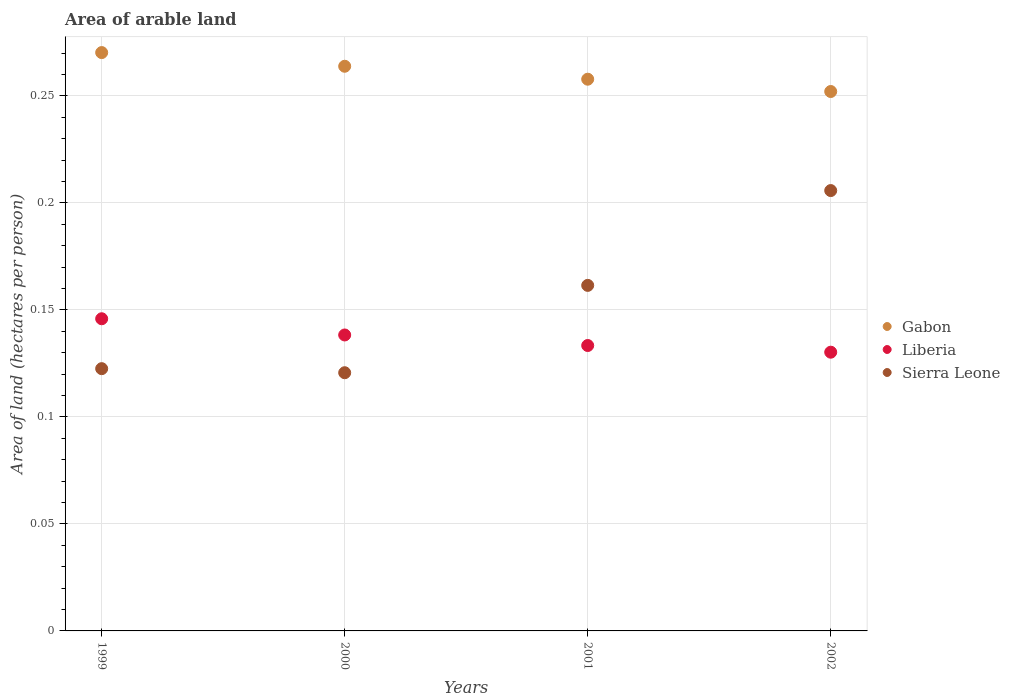How many different coloured dotlines are there?
Your answer should be very brief. 3. Is the number of dotlines equal to the number of legend labels?
Offer a terse response. Yes. What is the total arable land in Gabon in 2002?
Offer a terse response. 0.25. Across all years, what is the maximum total arable land in Sierra Leone?
Make the answer very short. 0.21. Across all years, what is the minimum total arable land in Sierra Leone?
Make the answer very short. 0.12. In which year was the total arable land in Gabon minimum?
Provide a succinct answer. 2002. What is the total total arable land in Liberia in the graph?
Offer a terse response. 0.55. What is the difference between the total arable land in Sierra Leone in 2001 and that in 2002?
Offer a terse response. -0.04. What is the difference between the total arable land in Liberia in 2002 and the total arable land in Gabon in 2000?
Keep it short and to the point. -0.13. What is the average total arable land in Liberia per year?
Offer a terse response. 0.14. In the year 2001, what is the difference between the total arable land in Liberia and total arable land in Gabon?
Make the answer very short. -0.12. What is the ratio of the total arable land in Sierra Leone in 1999 to that in 2000?
Make the answer very short. 1.02. Is the total arable land in Gabon in 1999 less than that in 2000?
Offer a very short reply. No. What is the difference between the highest and the second highest total arable land in Sierra Leone?
Your response must be concise. 0.04. What is the difference between the highest and the lowest total arable land in Liberia?
Keep it short and to the point. 0.02. In how many years, is the total arable land in Gabon greater than the average total arable land in Gabon taken over all years?
Your response must be concise. 2. Is the sum of the total arable land in Gabon in 2001 and 2002 greater than the maximum total arable land in Sierra Leone across all years?
Your answer should be compact. Yes. Does the total arable land in Sierra Leone monotonically increase over the years?
Keep it short and to the point. No. Is the total arable land in Liberia strictly less than the total arable land in Sierra Leone over the years?
Give a very brief answer. No. Are the values on the major ticks of Y-axis written in scientific E-notation?
Your response must be concise. No. How are the legend labels stacked?
Provide a short and direct response. Vertical. What is the title of the graph?
Make the answer very short. Area of arable land. Does "American Samoa" appear as one of the legend labels in the graph?
Offer a terse response. No. What is the label or title of the Y-axis?
Give a very brief answer. Area of land (hectares per person). What is the Area of land (hectares per person) in Gabon in 1999?
Your answer should be very brief. 0.27. What is the Area of land (hectares per person) of Liberia in 1999?
Make the answer very short. 0.15. What is the Area of land (hectares per person) in Sierra Leone in 1999?
Your response must be concise. 0.12. What is the Area of land (hectares per person) in Gabon in 2000?
Your response must be concise. 0.26. What is the Area of land (hectares per person) in Liberia in 2000?
Make the answer very short. 0.14. What is the Area of land (hectares per person) in Sierra Leone in 2000?
Give a very brief answer. 0.12. What is the Area of land (hectares per person) in Gabon in 2001?
Offer a terse response. 0.26. What is the Area of land (hectares per person) in Liberia in 2001?
Your response must be concise. 0.13. What is the Area of land (hectares per person) of Sierra Leone in 2001?
Offer a very short reply. 0.16. What is the Area of land (hectares per person) in Gabon in 2002?
Ensure brevity in your answer.  0.25. What is the Area of land (hectares per person) of Liberia in 2002?
Offer a terse response. 0.13. What is the Area of land (hectares per person) of Sierra Leone in 2002?
Offer a very short reply. 0.21. Across all years, what is the maximum Area of land (hectares per person) of Gabon?
Your answer should be very brief. 0.27. Across all years, what is the maximum Area of land (hectares per person) in Liberia?
Your answer should be very brief. 0.15. Across all years, what is the maximum Area of land (hectares per person) of Sierra Leone?
Offer a very short reply. 0.21. Across all years, what is the minimum Area of land (hectares per person) of Gabon?
Your answer should be very brief. 0.25. Across all years, what is the minimum Area of land (hectares per person) of Liberia?
Your answer should be compact. 0.13. Across all years, what is the minimum Area of land (hectares per person) of Sierra Leone?
Your answer should be very brief. 0.12. What is the total Area of land (hectares per person) of Gabon in the graph?
Keep it short and to the point. 1.04. What is the total Area of land (hectares per person) in Liberia in the graph?
Your answer should be compact. 0.55. What is the total Area of land (hectares per person) of Sierra Leone in the graph?
Make the answer very short. 0.61. What is the difference between the Area of land (hectares per person) of Gabon in 1999 and that in 2000?
Provide a short and direct response. 0.01. What is the difference between the Area of land (hectares per person) in Liberia in 1999 and that in 2000?
Give a very brief answer. 0.01. What is the difference between the Area of land (hectares per person) of Sierra Leone in 1999 and that in 2000?
Provide a succinct answer. 0. What is the difference between the Area of land (hectares per person) of Gabon in 1999 and that in 2001?
Keep it short and to the point. 0.01. What is the difference between the Area of land (hectares per person) in Liberia in 1999 and that in 2001?
Your answer should be compact. 0.01. What is the difference between the Area of land (hectares per person) in Sierra Leone in 1999 and that in 2001?
Provide a short and direct response. -0.04. What is the difference between the Area of land (hectares per person) in Gabon in 1999 and that in 2002?
Provide a short and direct response. 0.02. What is the difference between the Area of land (hectares per person) in Liberia in 1999 and that in 2002?
Keep it short and to the point. 0.02. What is the difference between the Area of land (hectares per person) in Sierra Leone in 1999 and that in 2002?
Ensure brevity in your answer.  -0.08. What is the difference between the Area of land (hectares per person) in Gabon in 2000 and that in 2001?
Your response must be concise. 0.01. What is the difference between the Area of land (hectares per person) in Liberia in 2000 and that in 2001?
Offer a terse response. 0. What is the difference between the Area of land (hectares per person) of Sierra Leone in 2000 and that in 2001?
Your answer should be very brief. -0.04. What is the difference between the Area of land (hectares per person) of Gabon in 2000 and that in 2002?
Your response must be concise. 0.01. What is the difference between the Area of land (hectares per person) of Liberia in 2000 and that in 2002?
Ensure brevity in your answer.  0.01. What is the difference between the Area of land (hectares per person) of Sierra Leone in 2000 and that in 2002?
Your answer should be very brief. -0.09. What is the difference between the Area of land (hectares per person) of Gabon in 2001 and that in 2002?
Your answer should be compact. 0.01. What is the difference between the Area of land (hectares per person) in Liberia in 2001 and that in 2002?
Your response must be concise. 0. What is the difference between the Area of land (hectares per person) of Sierra Leone in 2001 and that in 2002?
Offer a very short reply. -0.04. What is the difference between the Area of land (hectares per person) in Gabon in 1999 and the Area of land (hectares per person) in Liberia in 2000?
Make the answer very short. 0.13. What is the difference between the Area of land (hectares per person) in Gabon in 1999 and the Area of land (hectares per person) in Sierra Leone in 2000?
Provide a succinct answer. 0.15. What is the difference between the Area of land (hectares per person) of Liberia in 1999 and the Area of land (hectares per person) of Sierra Leone in 2000?
Make the answer very short. 0.03. What is the difference between the Area of land (hectares per person) in Gabon in 1999 and the Area of land (hectares per person) in Liberia in 2001?
Make the answer very short. 0.14. What is the difference between the Area of land (hectares per person) of Gabon in 1999 and the Area of land (hectares per person) of Sierra Leone in 2001?
Offer a very short reply. 0.11. What is the difference between the Area of land (hectares per person) of Liberia in 1999 and the Area of land (hectares per person) of Sierra Leone in 2001?
Ensure brevity in your answer.  -0.02. What is the difference between the Area of land (hectares per person) of Gabon in 1999 and the Area of land (hectares per person) of Liberia in 2002?
Provide a succinct answer. 0.14. What is the difference between the Area of land (hectares per person) of Gabon in 1999 and the Area of land (hectares per person) of Sierra Leone in 2002?
Offer a terse response. 0.06. What is the difference between the Area of land (hectares per person) of Liberia in 1999 and the Area of land (hectares per person) of Sierra Leone in 2002?
Ensure brevity in your answer.  -0.06. What is the difference between the Area of land (hectares per person) of Gabon in 2000 and the Area of land (hectares per person) of Liberia in 2001?
Keep it short and to the point. 0.13. What is the difference between the Area of land (hectares per person) of Gabon in 2000 and the Area of land (hectares per person) of Sierra Leone in 2001?
Give a very brief answer. 0.1. What is the difference between the Area of land (hectares per person) in Liberia in 2000 and the Area of land (hectares per person) in Sierra Leone in 2001?
Make the answer very short. -0.02. What is the difference between the Area of land (hectares per person) of Gabon in 2000 and the Area of land (hectares per person) of Liberia in 2002?
Provide a succinct answer. 0.13. What is the difference between the Area of land (hectares per person) in Gabon in 2000 and the Area of land (hectares per person) in Sierra Leone in 2002?
Provide a succinct answer. 0.06. What is the difference between the Area of land (hectares per person) of Liberia in 2000 and the Area of land (hectares per person) of Sierra Leone in 2002?
Offer a very short reply. -0.07. What is the difference between the Area of land (hectares per person) in Gabon in 2001 and the Area of land (hectares per person) in Liberia in 2002?
Offer a very short reply. 0.13. What is the difference between the Area of land (hectares per person) of Gabon in 2001 and the Area of land (hectares per person) of Sierra Leone in 2002?
Make the answer very short. 0.05. What is the difference between the Area of land (hectares per person) in Liberia in 2001 and the Area of land (hectares per person) in Sierra Leone in 2002?
Keep it short and to the point. -0.07. What is the average Area of land (hectares per person) of Gabon per year?
Give a very brief answer. 0.26. What is the average Area of land (hectares per person) in Liberia per year?
Provide a succinct answer. 0.14. What is the average Area of land (hectares per person) of Sierra Leone per year?
Provide a succinct answer. 0.15. In the year 1999, what is the difference between the Area of land (hectares per person) in Gabon and Area of land (hectares per person) in Liberia?
Your answer should be compact. 0.12. In the year 1999, what is the difference between the Area of land (hectares per person) in Gabon and Area of land (hectares per person) in Sierra Leone?
Offer a very short reply. 0.15. In the year 1999, what is the difference between the Area of land (hectares per person) of Liberia and Area of land (hectares per person) of Sierra Leone?
Your answer should be very brief. 0.02. In the year 2000, what is the difference between the Area of land (hectares per person) in Gabon and Area of land (hectares per person) in Liberia?
Your answer should be very brief. 0.13. In the year 2000, what is the difference between the Area of land (hectares per person) in Gabon and Area of land (hectares per person) in Sierra Leone?
Make the answer very short. 0.14. In the year 2000, what is the difference between the Area of land (hectares per person) in Liberia and Area of land (hectares per person) in Sierra Leone?
Your answer should be very brief. 0.02. In the year 2001, what is the difference between the Area of land (hectares per person) in Gabon and Area of land (hectares per person) in Liberia?
Your response must be concise. 0.12. In the year 2001, what is the difference between the Area of land (hectares per person) in Gabon and Area of land (hectares per person) in Sierra Leone?
Offer a very short reply. 0.1. In the year 2001, what is the difference between the Area of land (hectares per person) in Liberia and Area of land (hectares per person) in Sierra Leone?
Your answer should be very brief. -0.03. In the year 2002, what is the difference between the Area of land (hectares per person) in Gabon and Area of land (hectares per person) in Liberia?
Your answer should be very brief. 0.12. In the year 2002, what is the difference between the Area of land (hectares per person) of Gabon and Area of land (hectares per person) of Sierra Leone?
Make the answer very short. 0.05. In the year 2002, what is the difference between the Area of land (hectares per person) of Liberia and Area of land (hectares per person) of Sierra Leone?
Give a very brief answer. -0.08. What is the ratio of the Area of land (hectares per person) in Gabon in 1999 to that in 2000?
Offer a terse response. 1.02. What is the ratio of the Area of land (hectares per person) in Liberia in 1999 to that in 2000?
Your response must be concise. 1.05. What is the ratio of the Area of land (hectares per person) in Sierra Leone in 1999 to that in 2000?
Your answer should be compact. 1.02. What is the ratio of the Area of land (hectares per person) of Gabon in 1999 to that in 2001?
Make the answer very short. 1.05. What is the ratio of the Area of land (hectares per person) in Liberia in 1999 to that in 2001?
Keep it short and to the point. 1.09. What is the ratio of the Area of land (hectares per person) in Sierra Leone in 1999 to that in 2001?
Make the answer very short. 0.76. What is the ratio of the Area of land (hectares per person) of Gabon in 1999 to that in 2002?
Keep it short and to the point. 1.07. What is the ratio of the Area of land (hectares per person) of Liberia in 1999 to that in 2002?
Offer a terse response. 1.12. What is the ratio of the Area of land (hectares per person) of Sierra Leone in 1999 to that in 2002?
Your response must be concise. 0.6. What is the ratio of the Area of land (hectares per person) in Gabon in 2000 to that in 2001?
Ensure brevity in your answer.  1.02. What is the ratio of the Area of land (hectares per person) of Liberia in 2000 to that in 2001?
Make the answer very short. 1.04. What is the ratio of the Area of land (hectares per person) in Sierra Leone in 2000 to that in 2001?
Give a very brief answer. 0.75. What is the ratio of the Area of land (hectares per person) in Gabon in 2000 to that in 2002?
Provide a short and direct response. 1.05. What is the ratio of the Area of land (hectares per person) of Liberia in 2000 to that in 2002?
Your answer should be very brief. 1.06. What is the ratio of the Area of land (hectares per person) in Sierra Leone in 2000 to that in 2002?
Offer a very short reply. 0.59. What is the ratio of the Area of land (hectares per person) in Gabon in 2001 to that in 2002?
Provide a short and direct response. 1.02. What is the ratio of the Area of land (hectares per person) of Liberia in 2001 to that in 2002?
Your response must be concise. 1.02. What is the ratio of the Area of land (hectares per person) in Sierra Leone in 2001 to that in 2002?
Offer a very short reply. 0.78. What is the difference between the highest and the second highest Area of land (hectares per person) in Gabon?
Offer a very short reply. 0.01. What is the difference between the highest and the second highest Area of land (hectares per person) of Liberia?
Provide a short and direct response. 0.01. What is the difference between the highest and the second highest Area of land (hectares per person) of Sierra Leone?
Your response must be concise. 0.04. What is the difference between the highest and the lowest Area of land (hectares per person) in Gabon?
Make the answer very short. 0.02. What is the difference between the highest and the lowest Area of land (hectares per person) of Liberia?
Your response must be concise. 0.02. What is the difference between the highest and the lowest Area of land (hectares per person) of Sierra Leone?
Offer a very short reply. 0.09. 